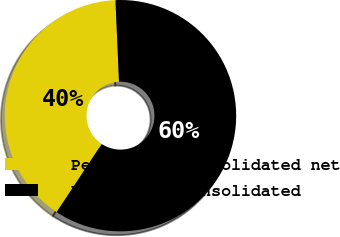<chart> <loc_0><loc_0><loc_500><loc_500><pie_chart><fcel>Percent of consolidated net<fcel>Percent of consolidated<nl><fcel>40.0%<fcel>60.0%<nl></chart> 